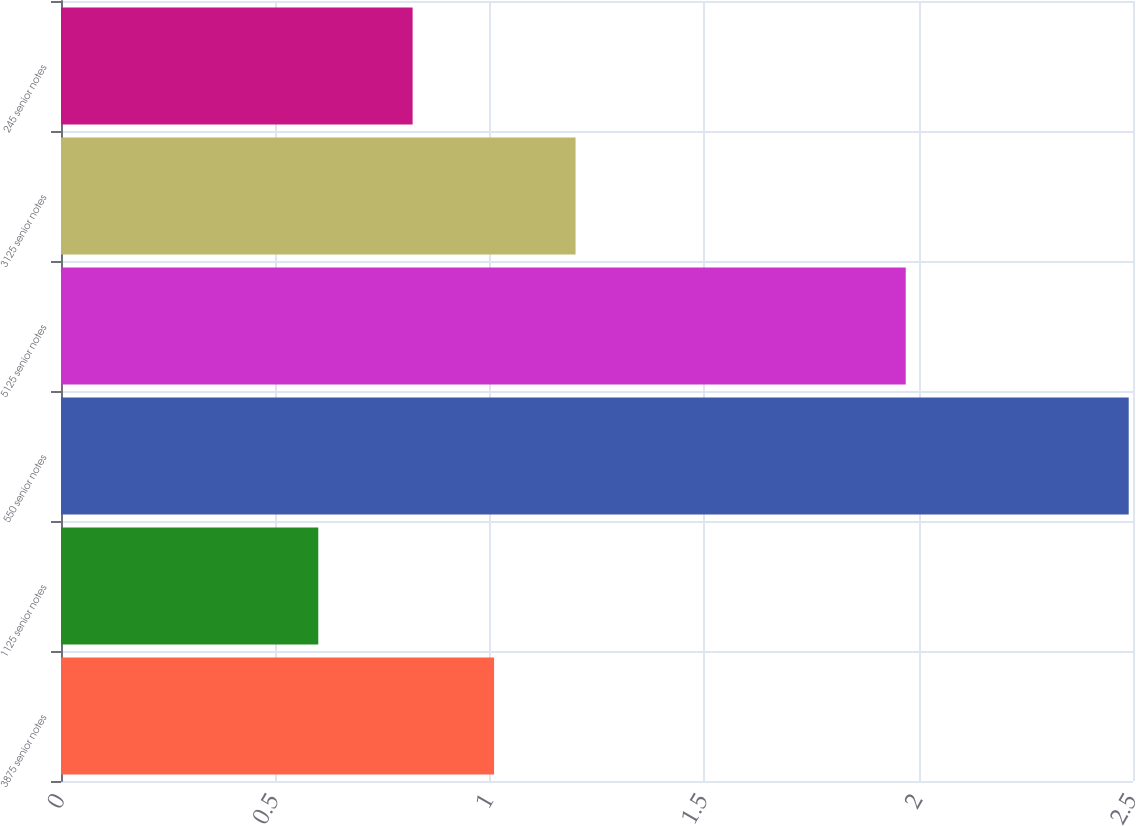Convert chart to OTSL. <chart><loc_0><loc_0><loc_500><loc_500><bar_chart><fcel>3875 senior notes<fcel>1125 senior notes<fcel>550 senior notes<fcel>5125 senior notes<fcel>3125 senior notes<fcel>245 senior notes<nl><fcel>1.01<fcel>0.6<fcel>2.49<fcel>1.97<fcel>1.2<fcel>0.82<nl></chart> 